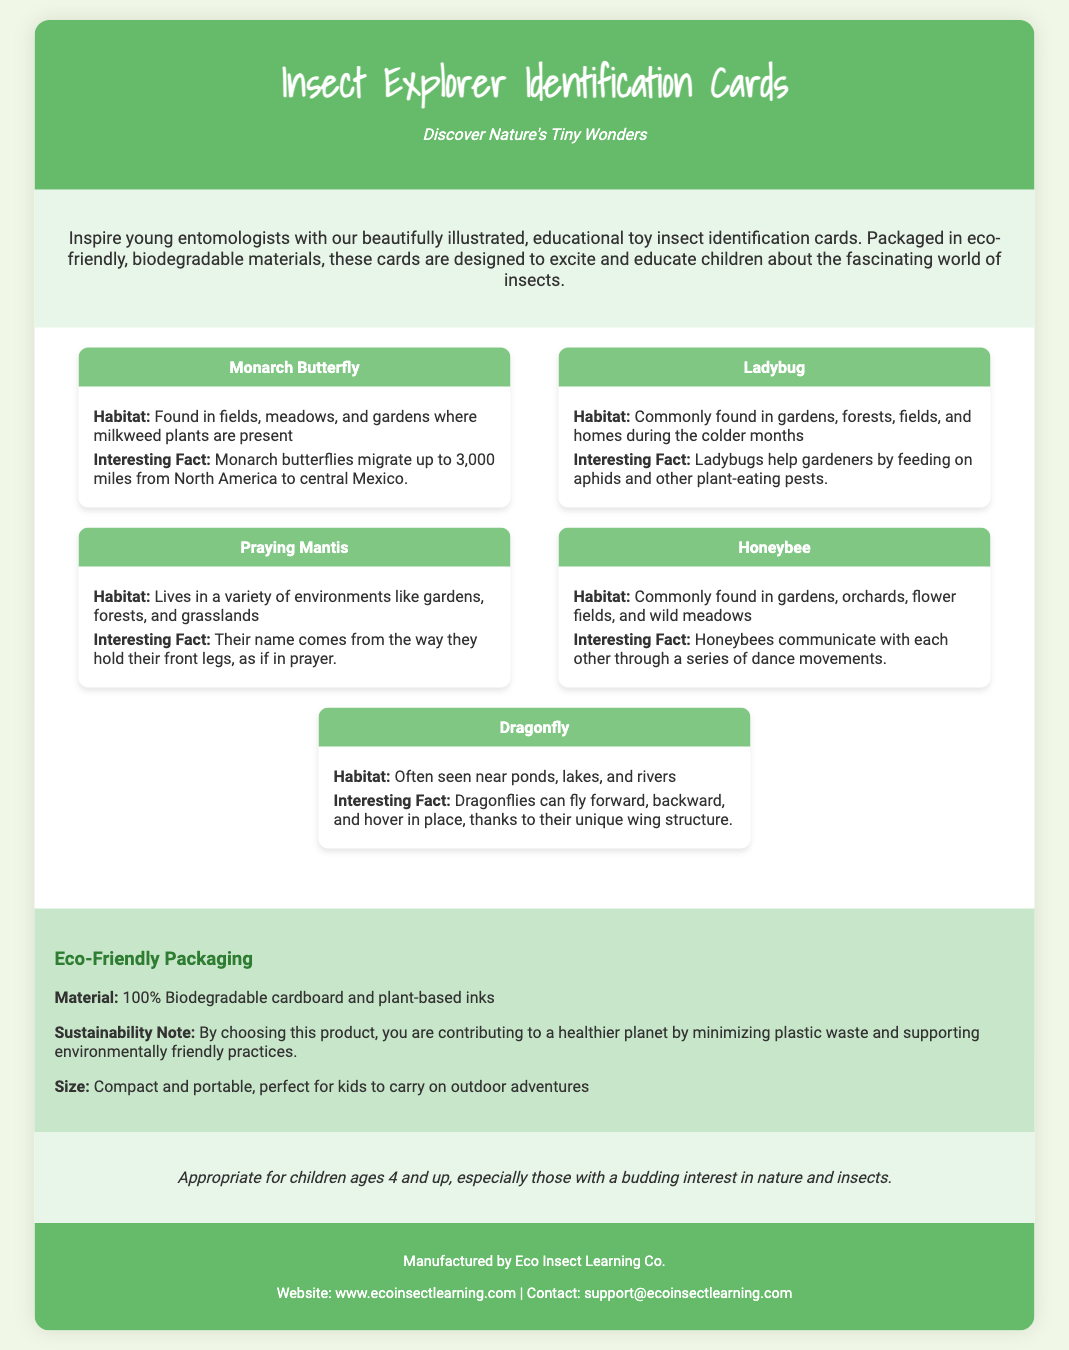what is the target age group for the insect identification cards? The target age group is mentioned in the document as appropriate for children ages 4 and up.
Answer: children ages 4 and up how many types of insects are featured in the cards? The document lists five different types of insects in the cards section.
Answer: five what material is used for the packaging of the insect identification cards? The document specifies that the packaging material is 100% biodegradable cardboard and plant-based inks.
Answer: 100% biodegradable cardboard and plant-based inks what interesting fact is associated with the Monarch Butterfly? The interesting fact provided for the Monarch Butterfly is that they migrate up to 3,000 miles from North America to central Mexico.
Answer: migrate up to 3,000 miles what is the main purpose of the insect identification cards? The main purpose, as described in the document, is to inspire young entomologists by educating them about insects.
Answer: inspire young entomologists what type of packaging is used for this educational toy? The packaging type emphasizes its eco-friendliness and biodegradability.
Answer: eco-friendly, biodegradable packaging which insect is known for its communication through dance movements? The Honeybee is specifically noted for communicating through dance movements.
Answer: Honeybee what colors are used in the card headers? The card headers feature a specific color scheme noted in the document, which is a shade of green.
Answer: green 